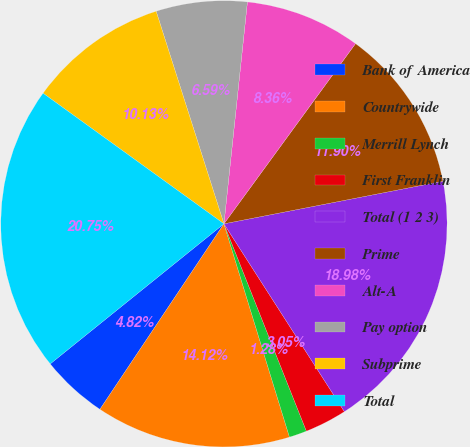<chart> <loc_0><loc_0><loc_500><loc_500><pie_chart><fcel>Bank of America<fcel>Countrywide<fcel>Merrill Lynch<fcel>First Franklin<fcel>Total (1 2 3)<fcel>Prime<fcel>Alt-A<fcel>Pay option<fcel>Subprime<fcel>Total<nl><fcel>4.82%<fcel>14.12%<fcel>1.28%<fcel>3.05%<fcel>18.98%<fcel>11.9%<fcel>8.36%<fcel>6.59%<fcel>10.13%<fcel>20.75%<nl></chart> 